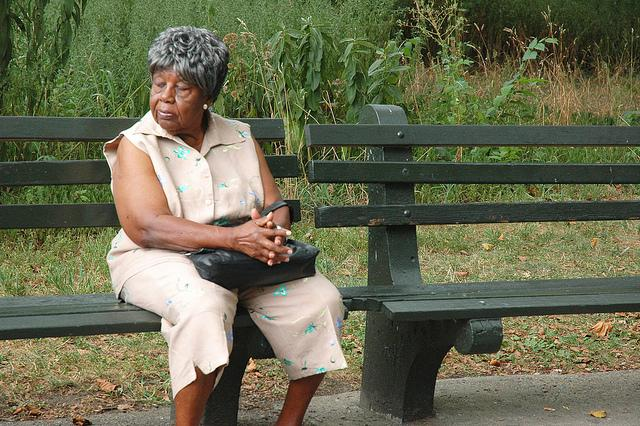What activity is the old lady engaging in?

Choices:
A) resting
B) crying
C) sleeping
D) praying resting 